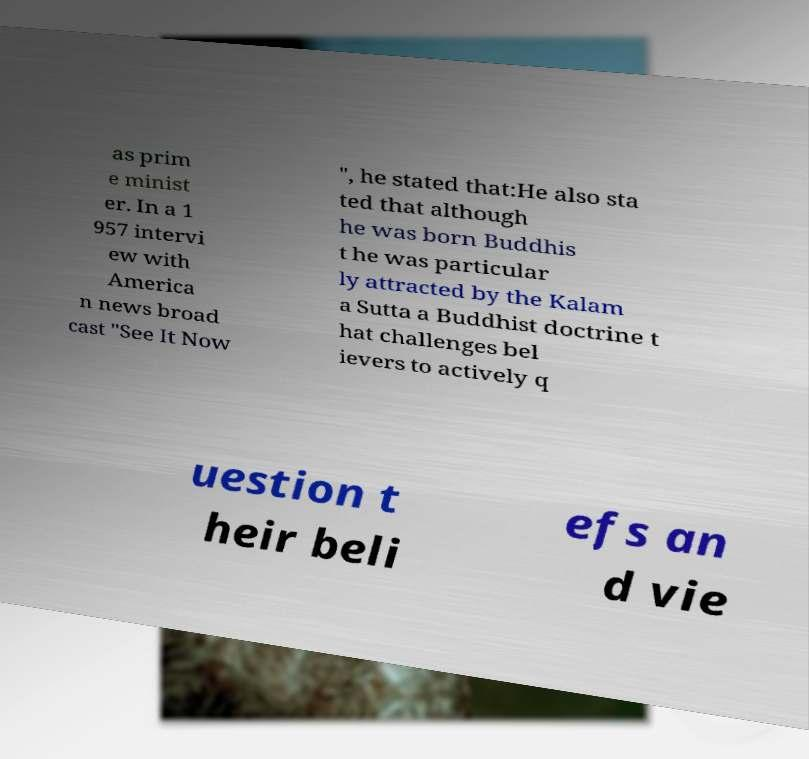Please identify and transcribe the text found in this image. as prim e minist er. In a 1 957 intervi ew with America n news broad cast "See It Now ", he stated that:He also sta ted that although he was born Buddhis t he was particular ly attracted by the Kalam a Sutta a Buddhist doctrine t hat challenges bel ievers to actively q uestion t heir beli efs an d vie 